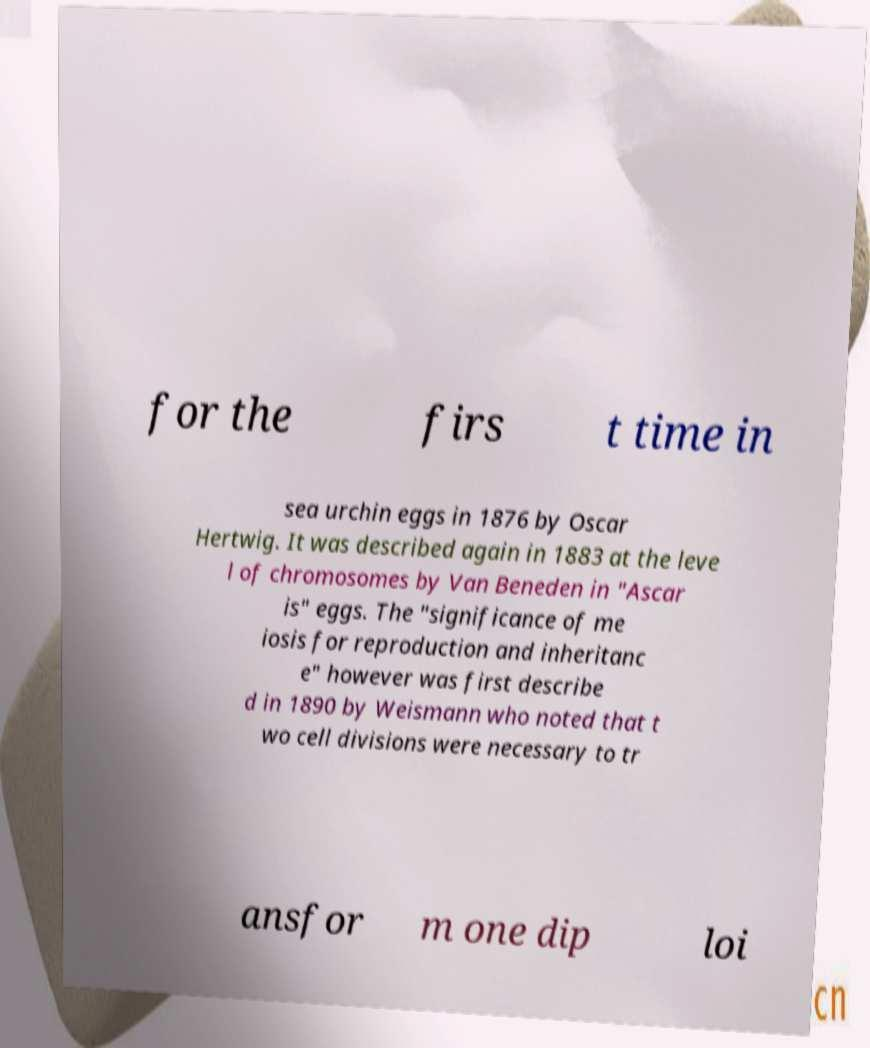Can you read and provide the text displayed in the image?This photo seems to have some interesting text. Can you extract and type it out for me? for the firs t time in sea urchin eggs in 1876 by Oscar Hertwig. It was described again in 1883 at the leve l of chromosomes by Van Beneden in "Ascar is" eggs. The "significance of me iosis for reproduction and inheritanc e" however was first describe d in 1890 by Weismann who noted that t wo cell divisions were necessary to tr ansfor m one dip loi 